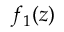<formula> <loc_0><loc_0><loc_500><loc_500>f _ { 1 } ( z )</formula> 